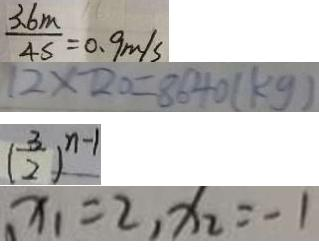Convert formula to latex. <formula><loc_0><loc_0><loc_500><loc_500>\frac { 3 . 6 m } { 4 s } = 0 . 9 m / s 
 1 2 \times 7 2 0 = 8 6 4 0 ( k g ) 
 ( \frac { 3 } { 2 } ) ^ { n - 1 } 
 x _ { 1 } = 2 , x _ { 2 } = - 1</formula> 